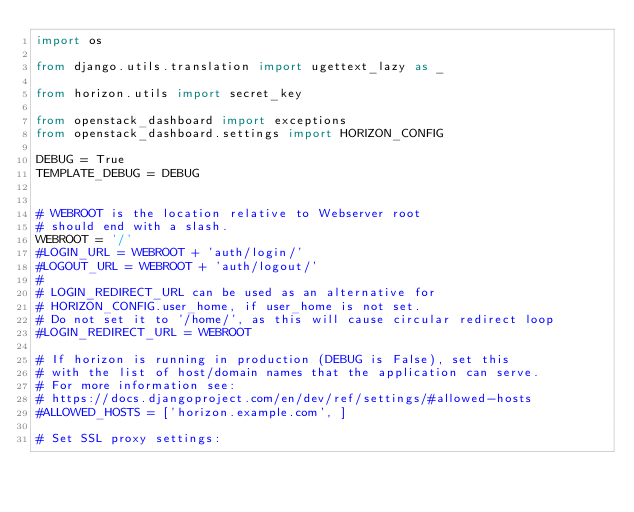<code> <loc_0><loc_0><loc_500><loc_500><_Python_>import os

from django.utils.translation import ugettext_lazy as _

from horizon.utils import secret_key

from openstack_dashboard import exceptions
from openstack_dashboard.settings import HORIZON_CONFIG

DEBUG = True
TEMPLATE_DEBUG = DEBUG


# WEBROOT is the location relative to Webserver root
# should end with a slash.
WEBROOT = '/'
#LOGIN_URL = WEBROOT + 'auth/login/'
#LOGOUT_URL = WEBROOT + 'auth/logout/'
#
# LOGIN_REDIRECT_URL can be used as an alternative for
# HORIZON_CONFIG.user_home, if user_home is not set.
# Do not set it to '/home/', as this will cause circular redirect loop
#LOGIN_REDIRECT_URL = WEBROOT

# If horizon is running in production (DEBUG is False), set this
# with the list of host/domain names that the application can serve.
# For more information see:
# https://docs.djangoproject.com/en/dev/ref/settings/#allowed-hosts
#ALLOWED_HOSTS = ['horizon.example.com', ]

# Set SSL proxy settings:</code> 